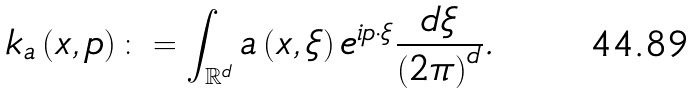<formula> <loc_0><loc_0><loc_500><loc_500>k _ { a } \left ( x , p \right ) \colon = \int _ { \mathbb { R } ^ { d } } a \left ( x , \xi \right ) e ^ { i p \cdot \xi } \frac { d \xi } { \left ( 2 \pi \right ) ^ { d } } .</formula> 